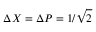<formula> <loc_0><loc_0><loc_500><loc_500>\Delta X = \Delta P = 1 / { \sqrt { 2 } }</formula> 